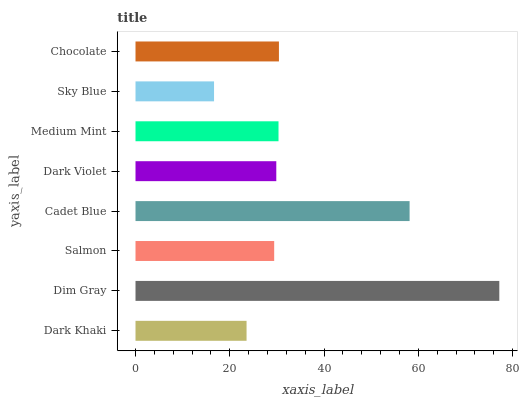Is Sky Blue the minimum?
Answer yes or no. Yes. Is Dim Gray the maximum?
Answer yes or no. Yes. Is Salmon the minimum?
Answer yes or no. No. Is Salmon the maximum?
Answer yes or no. No. Is Dim Gray greater than Salmon?
Answer yes or no. Yes. Is Salmon less than Dim Gray?
Answer yes or no. Yes. Is Salmon greater than Dim Gray?
Answer yes or no. No. Is Dim Gray less than Salmon?
Answer yes or no. No. Is Medium Mint the high median?
Answer yes or no. Yes. Is Dark Violet the low median?
Answer yes or no. Yes. Is Cadet Blue the high median?
Answer yes or no. No. Is Salmon the low median?
Answer yes or no. No. 